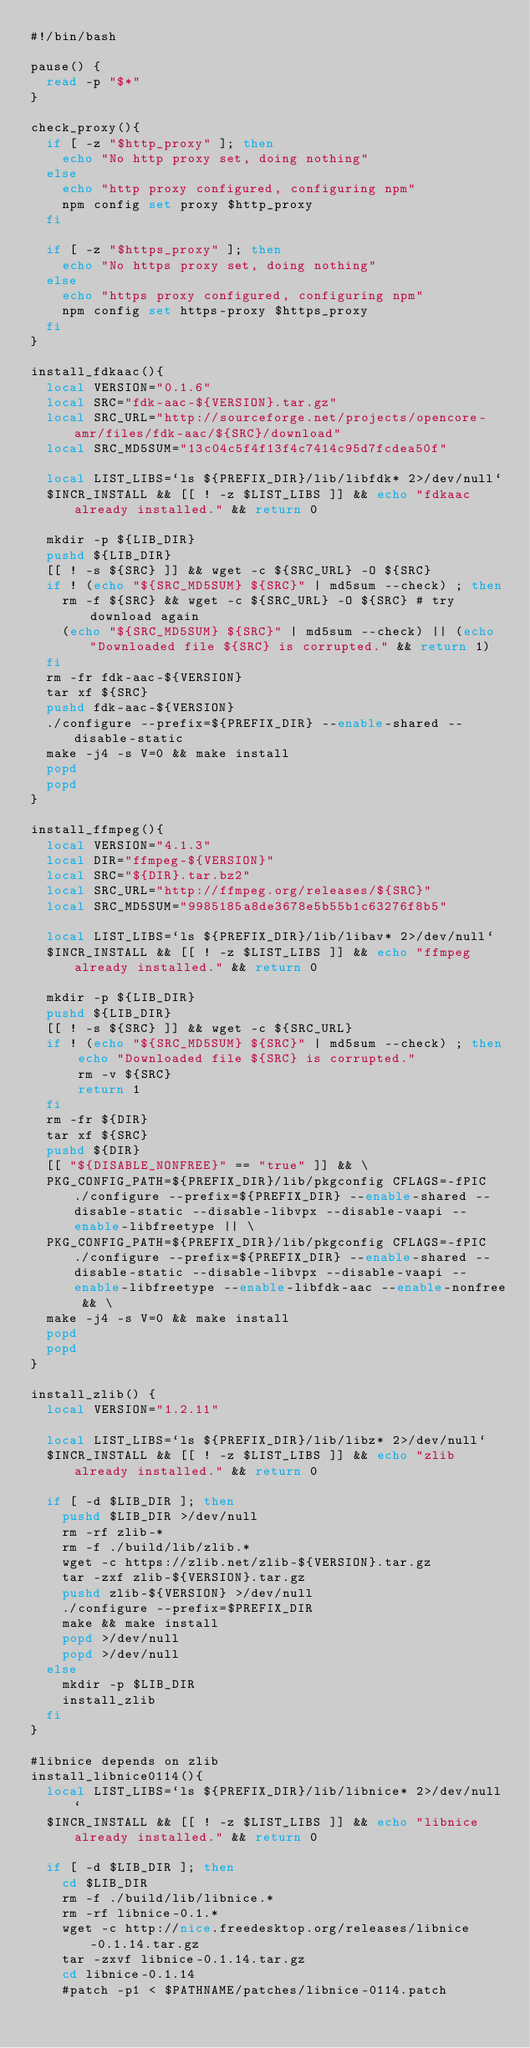Convert code to text. <code><loc_0><loc_0><loc_500><loc_500><_Bash_>#!/bin/bash

pause() {
  read -p "$*"
}

check_proxy(){
  if [ -z "$http_proxy" ]; then
    echo "No http proxy set, doing nothing"
  else
    echo "http proxy configured, configuring npm"
    npm config set proxy $http_proxy
  fi

  if [ -z "$https_proxy" ]; then
    echo "No https proxy set, doing nothing"
  else
    echo "https proxy configured, configuring npm"
    npm config set https-proxy $https_proxy
  fi
}

install_fdkaac(){
  local VERSION="0.1.6"
  local SRC="fdk-aac-${VERSION}.tar.gz"
  local SRC_URL="http://sourceforge.net/projects/opencore-amr/files/fdk-aac/${SRC}/download"
  local SRC_MD5SUM="13c04c5f4f13f4c7414c95d7fcdea50f"

  local LIST_LIBS=`ls ${PREFIX_DIR}/lib/libfdk* 2>/dev/null`
  $INCR_INSTALL && [[ ! -z $LIST_LIBS ]] && echo "fdkaac already installed." && return 0

  mkdir -p ${LIB_DIR}
  pushd ${LIB_DIR}
  [[ ! -s ${SRC} ]] && wget -c ${SRC_URL} -O ${SRC}
  if ! (echo "${SRC_MD5SUM} ${SRC}" | md5sum --check) ; then
    rm -f ${SRC} && wget -c ${SRC_URL} -O ${SRC} # try download again
    (echo "${SRC_MD5SUM} ${SRC}" | md5sum --check) || (echo "Downloaded file ${SRC} is corrupted." && return 1)
  fi
  rm -fr fdk-aac-${VERSION}
  tar xf ${SRC}
  pushd fdk-aac-${VERSION}
  ./configure --prefix=${PREFIX_DIR} --enable-shared --disable-static
  make -j4 -s V=0 && make install
  popd
  popd
}

install_ffmpeg(){
  local VERSION="4.1.3"
  local DIR="ffmpeg-${VERSION}"
  local SRC="${DIR}.tar.bz2"
  local SRC_URL="http://ffmpeg.org/releases/${SRC}"
  local SRC_MD5SUM="9985185a8de3678e5b55b1c63276f8b5"

  local LIST_LIBS=`ls ${PREFIX_DIR}/lib/libav* 2>/dev/null`
  $INCR_INSTALL && [[ ! -z $LIST_LIBS ]] && echo "ffmpeg already installed." && return 0

  mkdir -p ${LIB_DIR}
  pushd ${LIB_DIR}
  [[ ! -s ${SRC} ]] && wget -c ${SRC_URL}
  if ! (echo "${SRC_MD5SUM} ${SRC}" | md5sum --check) ; then
      echo "Downloaded file ${SRC} is corrupted."
      rm -v ${SRC}
      return 1
  fi
  rm -fr ${DIR}
  tar xf ${SRC}
  pushd ${DIR}
  [[ "${DISABLE_NONFREE}" == "true" ]] && \
  PKG_CONFIG_PATH=${PREFIX_DIR}/lib/pkgconfig CFLAGS=-fPIC ./configure --prefix=${PREFIX_DIR} --enable-shared --disable-static --disable-libvpx --disable-vaapi --enable-libfreetype || \
  PKG_CONFIG_PATH=${PREFIX_DIR}/lib/pkgconfig CFLAGS=-fPIC ./configure --prefix=${PREFIX_DIR} --enable-shared --disable-static --disable-libvpx --disable-vaapi --enable-libfreetype --enable-libfdk-aac --enable-nonfree && \
  make -j4 -s V=0 && make install
  popd
  popd
}

install_zlib() {
  local VERSION="1.2.11"

  local LIST_LIBS=`ls ${PREFIX_DIR}/lib/libz* 2>/dev/null`
  $INCR_INSTALL && [[ ! -z $LIST_LIBS ]] && echo "zlib already installed." && return 0

  if [ -d $LIB_DIR ]; then
    pushd $LIB_DIR >/dev/null
    rm -rf zlib-*
    rm -f ./build/lib/zlib.*
    wget -c https://zlib.net/zlib-${VERSION}.tar.gz
    tar -zxf zlib-${VERSION}.tar.gz
    pushd zlib-${VERSION} >/dev/null
    ./configure --prefix=$PREFIX_DIR
    make && make install
    popd >/dev/null
    popd >/dev/null
  else
    mkdir -p $LIB_DIR
    install_zlib
  fi
}

#libnice depends on zlib
install_libnice0114(){
  local LIST_LIBS=`ls ${PREFIX_DIR}/lib/libnice* 2>/dev/null`
  $INCR_INSTALL && [[ ! -z $LIST_LIBS ]] && echo "libnice already installed." && return 0

  if [ -d $LIB_DIR ]; then
    cd $LIB_DIR
    rm -f ./build/lib/libnice.*
    rm -rf libnice-0.1.*
    wget -c http://nice.freedesktop.org/releases/libnice-0.1.14.tar.gz
    tar -zxvf libnice-0.1.14.tar.gz
    cd libnice-0.1.14
    #patch -p1 < $PATHNAME/patches/libnice-0114.patch</code> 